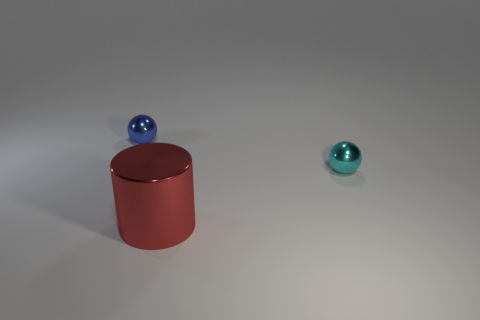Is the material of the blue sphere the same as the red cylinder?
Provide a succinct answer. Yes. What number of other objects are there of the same color as the big object?
Your answer should be compact. 0. Is the number of small cyan objects greater than the number of big purple rubber blocks?
Provide a succinct answer. Yes. There is a cyan object; does it have the same size as the metallic ball to the left of the cyan metal ball?
Ensure brevity in your answer.  Yes. There is a tiny sphere that is left of the red cylinder; what color is it?
Your response must be concise. Blue. How many green objects are either shiny things or balls?
Keep it short and to the point. 0. The large cylinder has what color?
Make the answer very short. Red. Is the number of tiny cyan metal objects that are in front of the cylinder less than the number of spheres in front of the small blue ball?
Your response must be concise. Yes. What is the shape of the object that is left of the cyan object and behind the cylinder?
Provide a short and direct response. Sphere. How many other red things are the same shape as the big red thing?
Give a very brief answer. 0. 